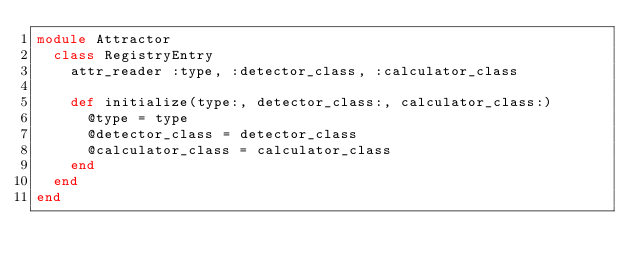Convert code to text. <code><loc_0><loc_0><loc_500><loc_500><_Ruby_>module Attractor
  class RegistryEntry
    attr_reader :type, :detector_class, :calculator_class

    def initialize(type:, detector_class:, calculator_class:)
      @type = type
      @detector_class = detector_class
      @calculator_class = calculator_class
    end
  end
end

</code> 